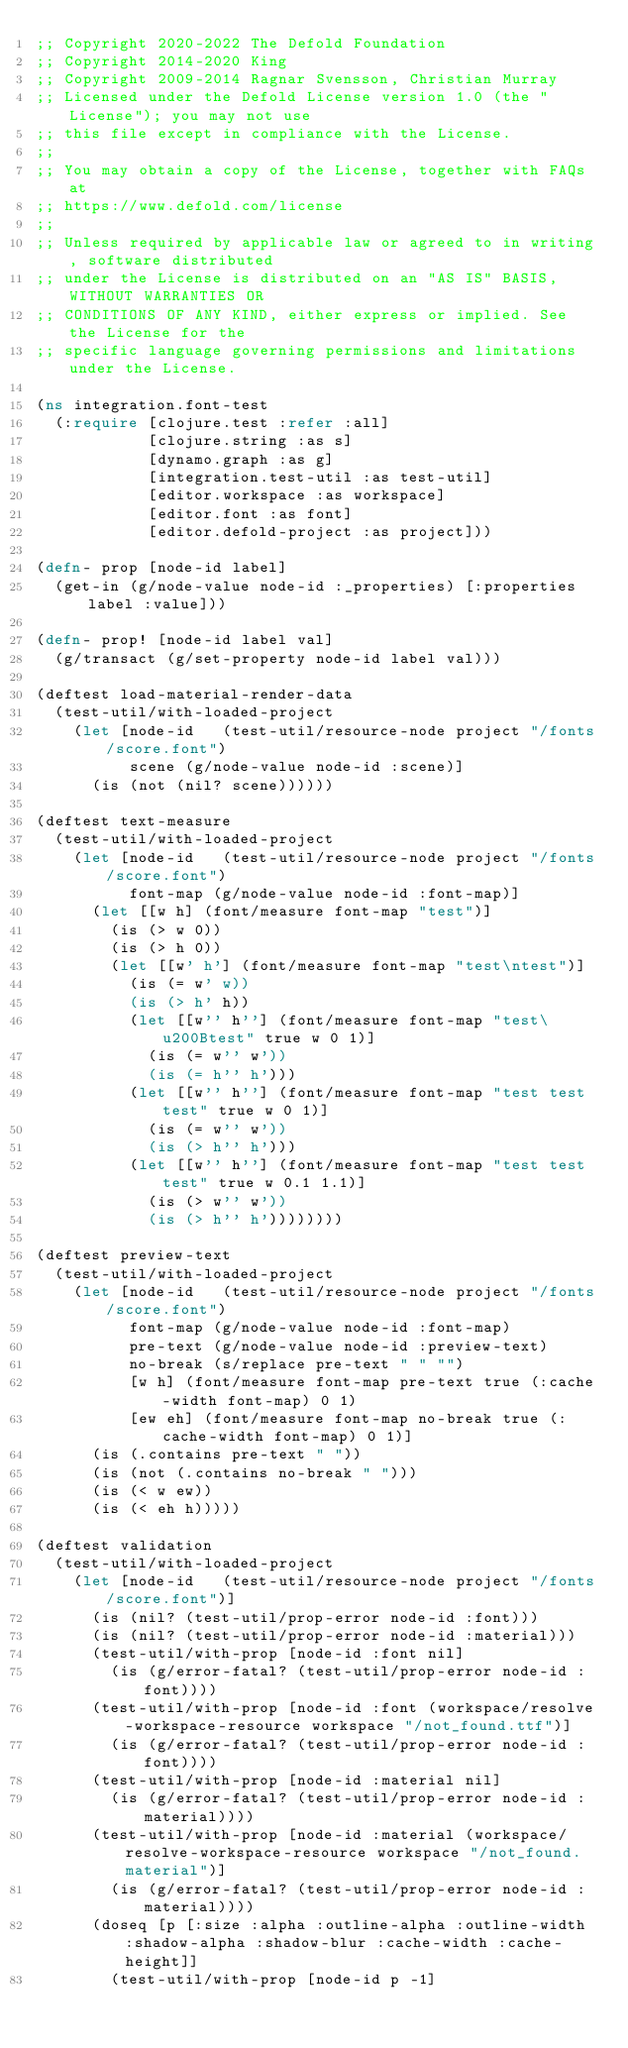Convert code to text. <code><loc_0><loc_0><loc_500><loc_500><_Clojure_>;; Copyright 2020-2022 The Defold Foundation
;; Copyright 2014-2020 King
;; Copyright 2009-2014 Ragnar Svensson, Christian Murray
;; Licensed under the Defold License version 1.0 (the "License"); you may not use
;; this file except in compliance with the License.
;; 
;; You may obtain a copy of the License, together with FAQs at
;; https://www.defold.com/license
;; 
;; Unless required by applicable law or agreed to in writing, software distributed
;; under the License is distributed on an "AS IS" BASIS, WITHOUT WARRANTIES OR
;; CONDITIONS OF ANY KIND, either express or implied. See the License for the
;; specific language governing permissions and limitations under the License.

(ns integration.font-test
  (:require [clojure.test :refer :all]
            [clojure.string :as s]
            [dynamo.graph :as g]
            [integration.test-util :as test-util]
            [editor.workspace :as workspace]
            [editor.font :as font]
            [editor.defold-project :as project]))

(defn- prop [node-id label]
  (get-in (g/node-value node-id :_properties) [:properties label :value]))

(defn- prop! [node-id label val]
  (g/transact (g/set-property node-id label val)))

(deftest load-material-render-data
  (test-util/with-loaded-project
    (let [node-id   (test-util/resource-node project "/fonts/score.font")
          scene (g/node-value node-id :scene)]
      (is (not (nil? scene))))))

(deftest text-measure
  (test-util/with-loaded-project
    (let [node-id   (test-util/resource-node project "/fonts/score.font")
          font-map (g/node-value node-id :font-map)]
      (let [[w h] (font/measure font-map "test")]
        (is (> w 0))
        (is (> h 0))
        (let [[w' h'] (font/measure font-map "test\ntest")]
          (is (= w' w))
          (is (> h' h))
          (let [[w'' h''] (font/measure font-map "test\u200Btest" true w 0 1)]
            (is (= w'' w'))
            (is (= h'' h')))
          (let [[w'' h''] (font/measure font-map "test test test" true w 0 1)]
            (is (= w'' w'))
            (is (> h'' h')))
          (let [[w'' h''] (font/measure font-map "test test test" true w 0.1 1.1)]
            (is (> w'' w'))
            (is (> h'' h'))))))))

(deftest preview-text
  (test-util/with-loaded-project
    (let [node-id   (test-util/resource-node project "/fonts/score.font")
          font-map (g/node-value node-id :font-map)
          pre-text (g/node-value node-id :preview-text)
          no-break (s/replace pre-text " " "")
          [w h] (font/measure font-map pre-text true (:cache-width font-map) 0 1)
          [ew eh] (font/measure font-map no-break true (:cache-width font-map) 0 1)]
      (is (.contains pre-text " "))
      (is (not (.contains no-break " ")))
      (is (< w ew))
      (is (< eh h)))))

(deftest validation
  (test-util/with-loaded-project
    (let [node-id   (test-util/resource-node project "/fonts/score.font")]
      (is (nil? (test-util/prop-error node-id :font)))
      (is (nil? (test-util/prop-error node-id :material)))
      (test-util/with-prop [node-id :font nil]
        (is (g/error-fatal? (test-util/prop-error node-id :font))))
      (test-util/with-prop [node-id :font (workspace/resolve-workspace-resource workspace "/not_found.ttf")]
        (is (g/error-fatal? (test-util/prop-error node-id :font))))
      (test-util/with-prop [node-id :material nil]
        (is (g/error-fatal? (test-util/prop-error node-id :material))))
      (test-util/with-prop [node-id :material (workspace/resolve-workspace-resource workspace "/not_found.material")]
        (is (g/error-fatal? (test-util/prop-error node-id :material))))
      (doseq [p [:size :alpha :outline-alpha :outline-width :shadow-alpha :shadow-blur :cache-width :cache-height]]
        (test-util/with-prop [node-id p -1]</code> 